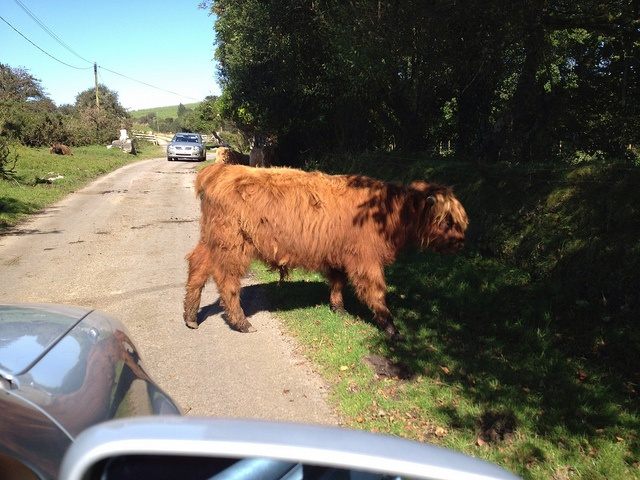Describe the objects in this image and their specific colors. I can see cow in lightblue, tan, black, salmon, and brown tones, car in lightblue, darkgray, gray, and black tones, car in lightblue, white, darkgray, and gray tones, and cow in lightblue, gray, tan, black, and brown tones in this image. 